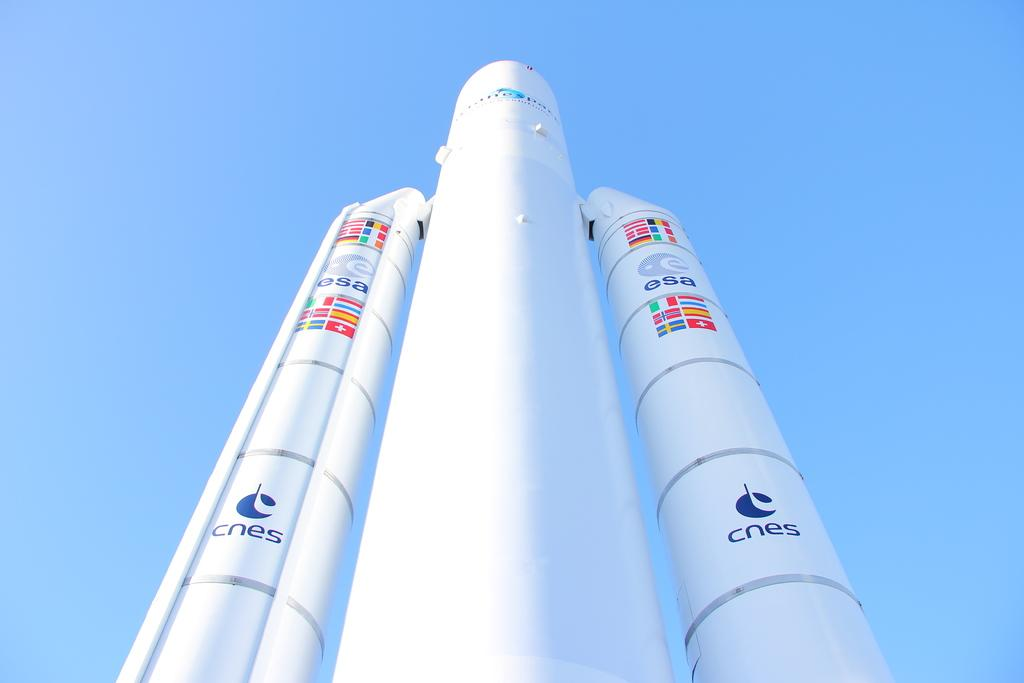What is the main subject in the center of the image? There is a rocket in the center of the image. What can be seen in the background of the image? There is sky visible in the background of the image. What type of toothpaste is being used to clean the rocket in the image? There is no toothpaste or cleaning activity depicted in the image; it features a rocket in the center and sky in the background. 